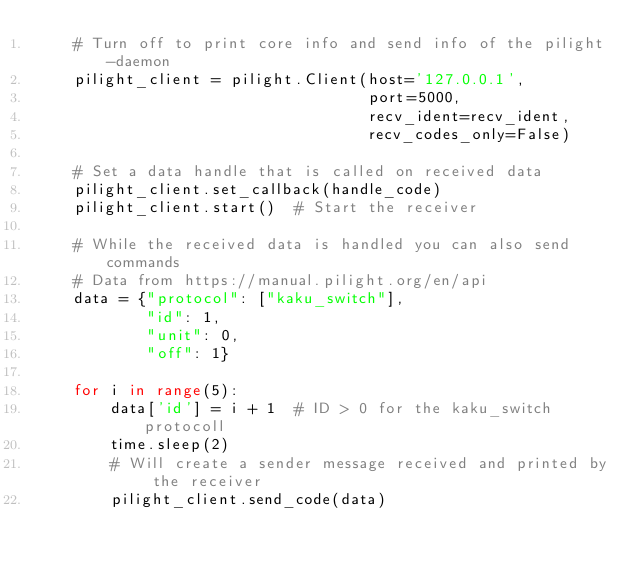<code> <loc_0><loc_0><loc_500><loc_500><_Python_>    # Turn off to print core info and send info of the pilight-daemon
    pilight_client = pilight.Client(host='127.0.0.1',
                                    port=5000,
                                    recv_ident=recv_ident,
                                    recv_codes_only=False)

    # Set a data handle that is called on received data
    pilight_client.set_callback(handle_code)
    pilight_client.start()  # Start the receiver

    # While the received data is handled you can also send commands
    # Data from https://manual.pilight.org/en/api
    data = {"protocol": ["kaku_switch"],
            "id": 1,
            "unit": 0,
            "off": 1}

    for i in range(5):
        data['id'] = i + 1  # ID > 0 for the kaku_switch protocoll
        time.sleep(2)
        # Will create a sender message received and printed by the receiver
        pilight_client.send_code(data)
</code> 